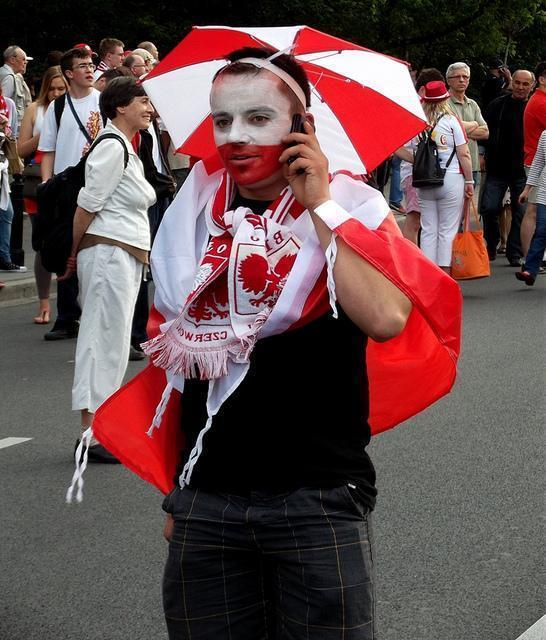Which country has red with white flag?
Select the accurate answer and provide explanation: 'Answer: answer
Rationale: rationale.'
Options: Dutch, poland, turkey, russia. Answer: poland.
Rationale: Poland's flag is red and white. 